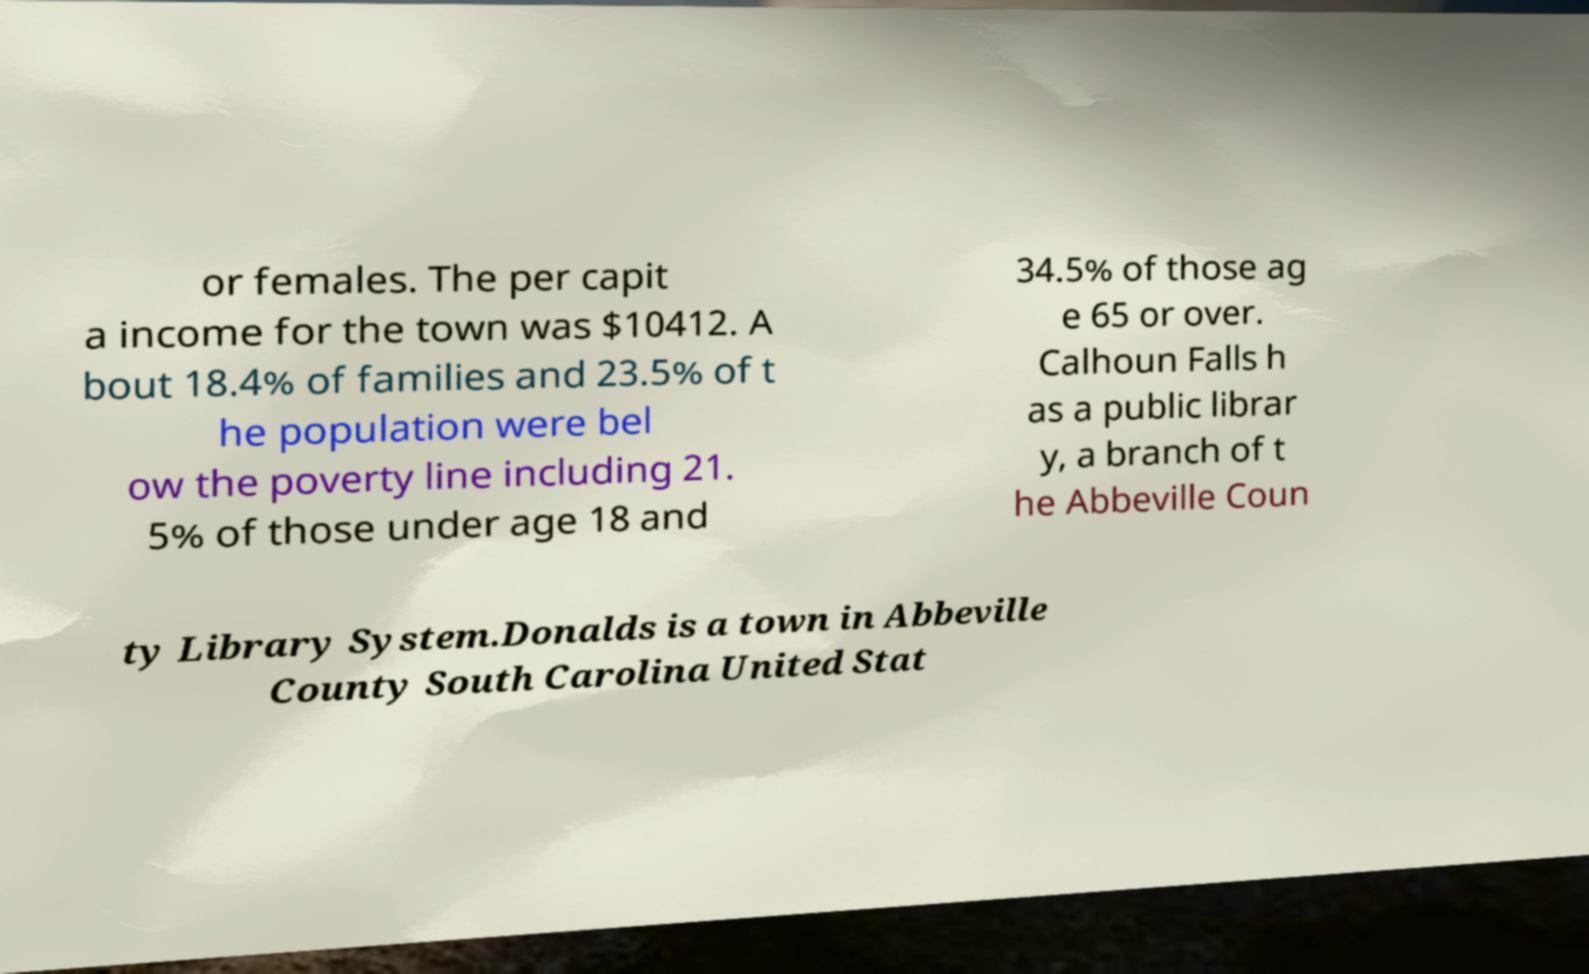Could you extract and type out the text from this image? or females. The per capit a income for the town was $10412. A bout 18.4% of families and 23.5% of t he population were bel ow the poverty line including 21. 5% of those under age 18 and 34.5% of those ag e 65 or over. Calhoun Falls h as a public librar y, a branch of t he Abbeville Coun ty Library System.Donalds is a town in Abbeville County South Carolina United Stat 